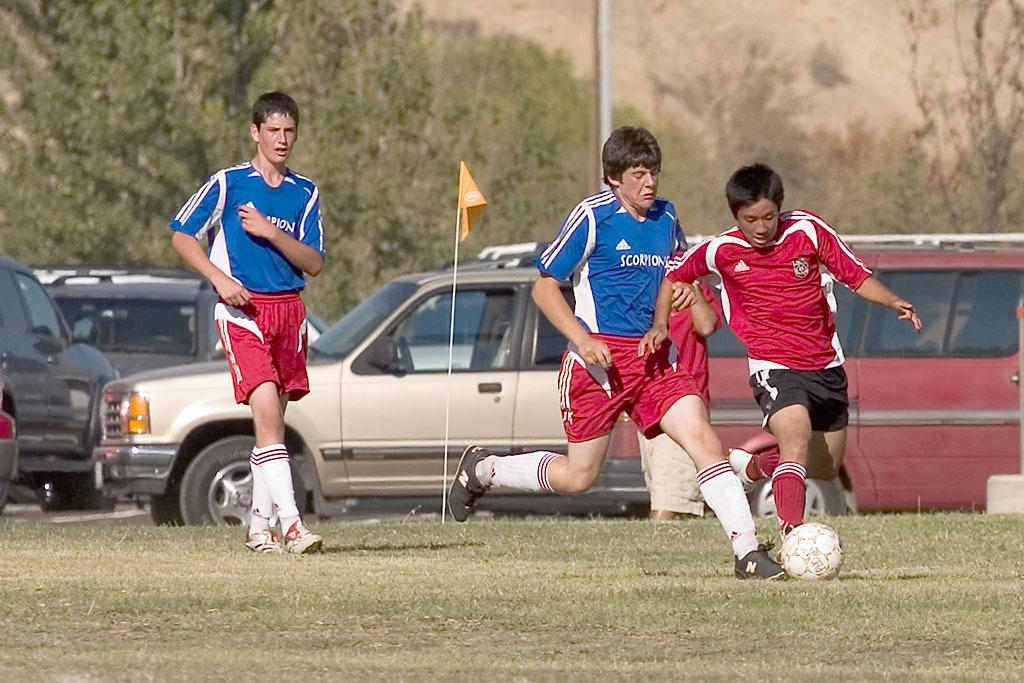How many people are playing football in the image? There are three persons in the image playing football. Where is the football game taking place? The football game is taking place on a ground. What can be seen in the background of the image? There is a car, a small flag, and a tree in the background of the image. What type of bread is being exchanged between the players during the football game? There is no bread or exchange of any kind taking place during the football game in the image. 